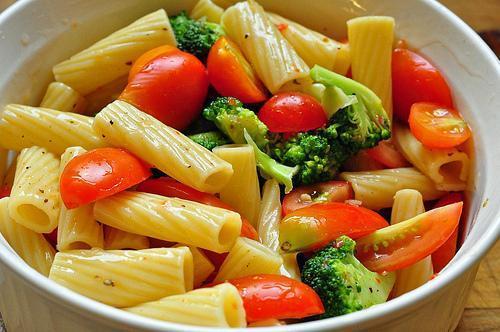How many different ingredients are visible?
Give a very brief answer. 3. 